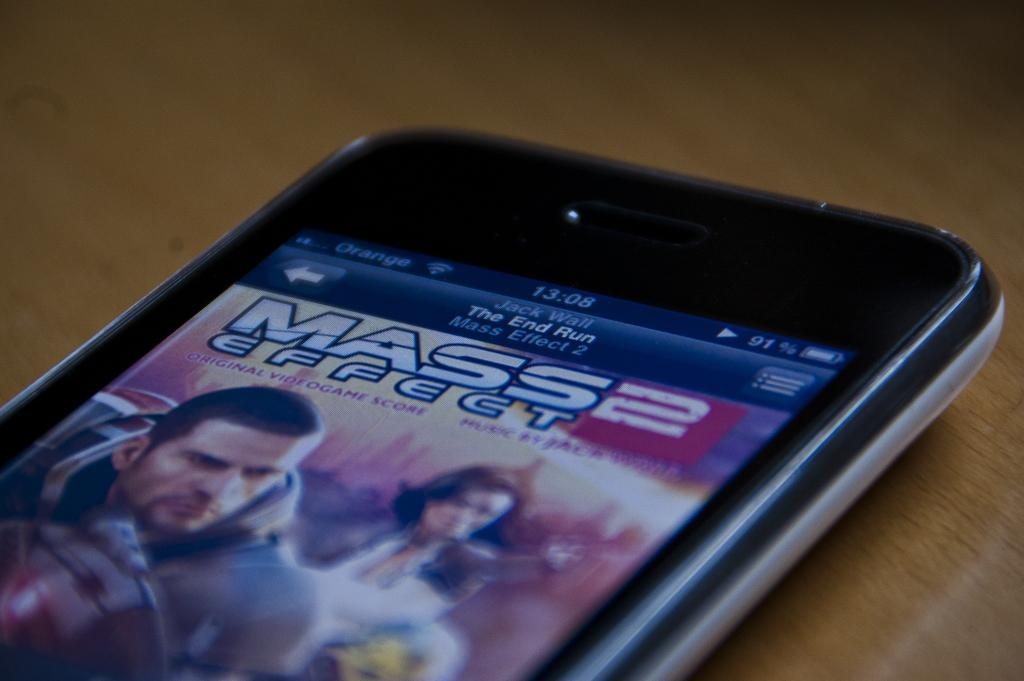What type of surface is visible in the image? There is a wooden surface in the image. What is placed on the wooden surface? There is an electronic device on the wooden surface. What feature does the electronic device have? The electronic device has a screen. What type of shirt is the laborer wearing in the image? There is no laborer or shirt present in the image. Can you describe the bee's activity in the image? There are no bees present in the image. 